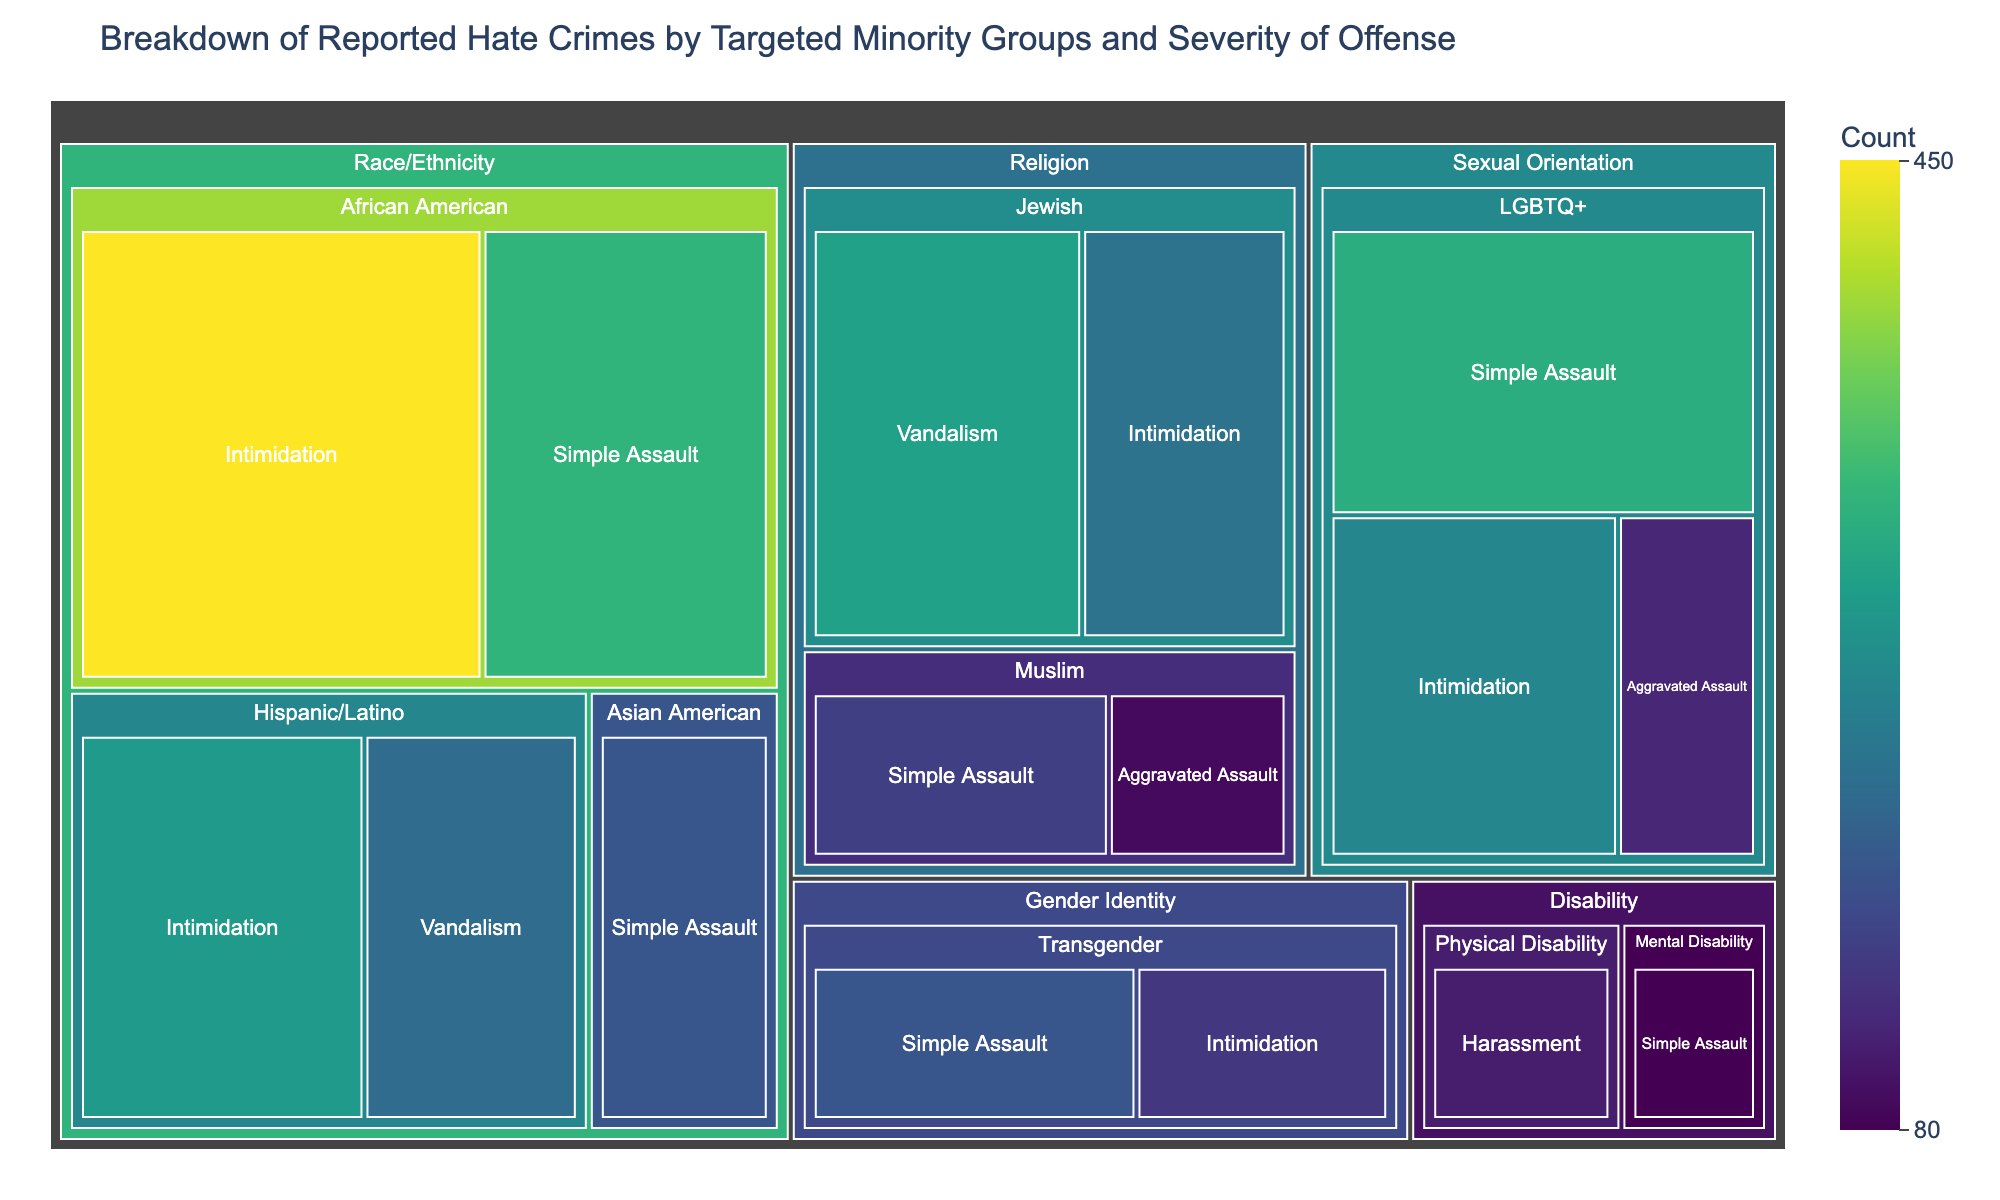How many total hate crimes were reported against African Americans? Sum the counts for African Americans: 450 (Intimidation) + 320 (Simple Assault) = 770.
Answer: 770 Which targeted minority group and offense have the highest count? The treemap will show that "African American" under "Race/Ethnicity" with "Intimidation" has the highest count of 450.
Answer: African American, Intimidation What is the total number of hate crimes reported under "Sexual Orientation"? Sum the counts for the offenses under Sexual Orientation: 310 (Simple Assault) + 250 (Intimidation) + 120 (Aggravated Assault) = 680.
Answer: 680 Are hate crimes against African Americans or Jewish people reported more frequently? Sum the counts for African Americans: 450 (Intimidation) + 320 (Simple Assault) = 770 and for Jewish: 290 (Vandalism) + 220 (Intimidation) = 510. Compare totals: 770 vs. 510.
Answer: African Americans Which offense is most commonly reported for Transgender individuals? Check the counts for offenses under Transgender: Simple Assault (180), Intimidation (140). The highest count is for Simple Assault.
Answer: Simple Assault How do the reported hate crimes for Physical Disability compare to those for Mental Disability? Physical Disability has a count of 110 (Harassment), and Mental Disability has a count of 80 (Simple Assault). Compare the two counts: 110 vs. 80.
Answer: Physical Disability has more What category has the most diverse range of offenses reported (most different types of offenses)? Count the number of distinct offenses under each category. Race/Ethnicity: 4, Religion: 4, Sexual Orientation: 3, Gender Identity: 2, Disability: 2. Race/Ethnicity and Religion both have 4.
Answer: Race/Ethnicity, Religion Which group has the highest count of Vandalism offenses? Check the counts for Vandalism offenses: Hispanic/Latino (210) and Jewish (290). The highest count is 290 for Jewish individuals.
Answer: Jewish 